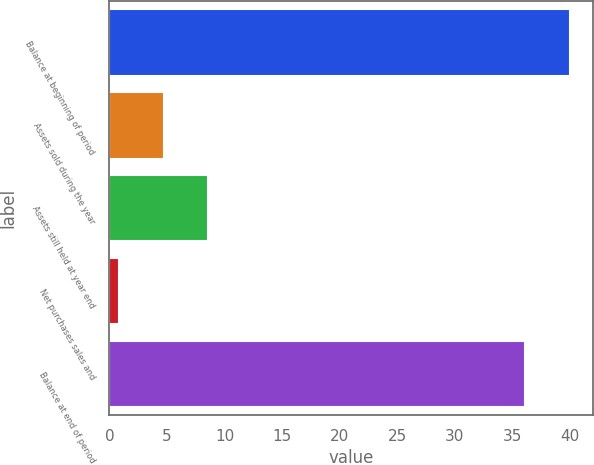Convert chart. <chart><loc_0><loc_0><loc_500><loc_500><bar_chart><fcel>Balance at beginning of period<fcel>Assets sold during the year<fcel>Assets still held at year end<fcel>Net purchases sales and<fcel>Balance at end of period<nl><fcel>40<fcel>4.7<fcel>8.6<fcel>0.8<fcel>36.1<nl></chart> 